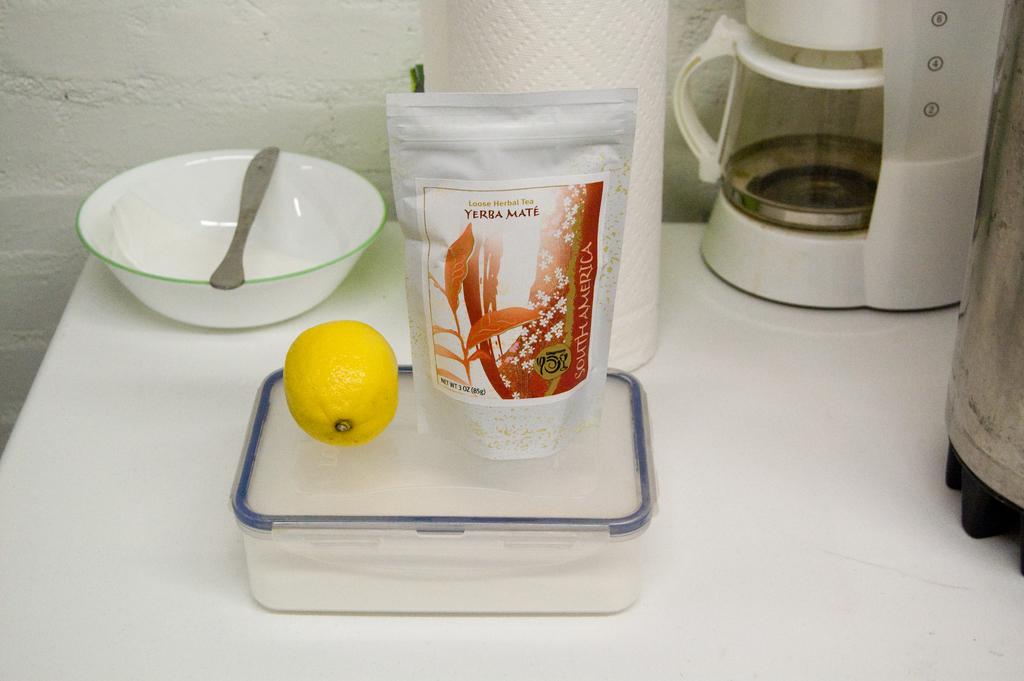What is inside of the packet?
Provide a succinct answer. Yerba mate. Is this from yerba mate?
Offer a terse response. Yes. 